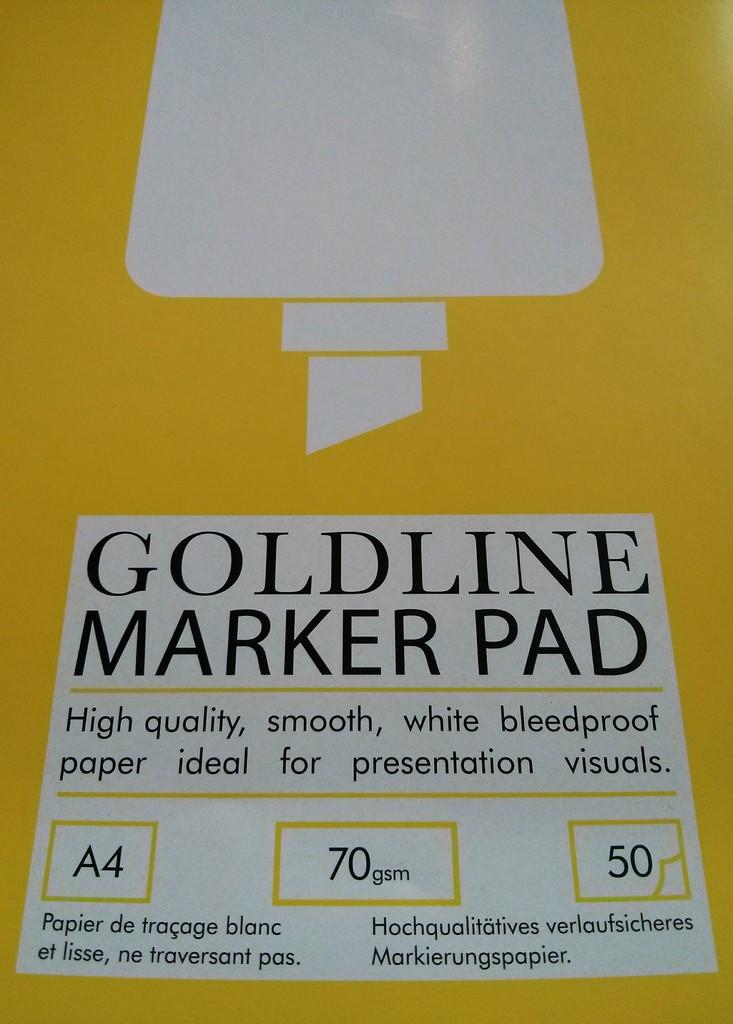What type of paper is this?
Make the answer very short. Goldline marker pad. How much paper is in this?
Your answer should be compact. 50. 